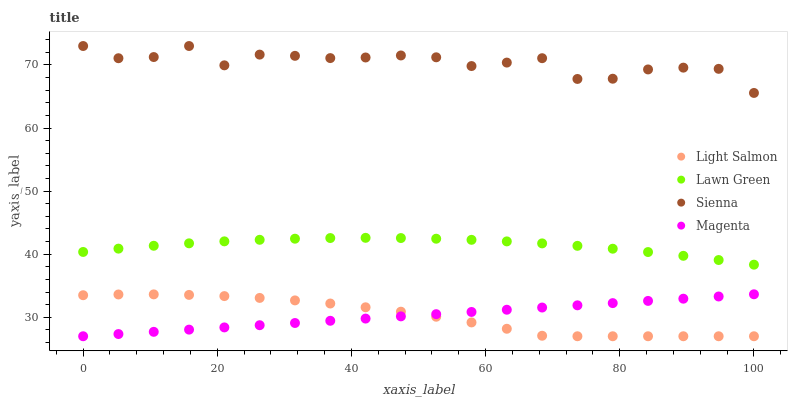Does Light Salmon have the minimum area under the curve?
Answer yes or no. Yes. Does Sienna have the maximum area under the curve?
Answer yes or no. Yes. Does Lawn Green have the minimum area under the curve?
Answer yes or no. No. Does Lawn Green have the maximum area under the curve?
Answer yes or no. No. Is Magenta the smoothest?
Answer yes or no. Yes. Is Sienna the roughest?
Answer yes or no. Yes. Is Lawn Green the smoothest?
Answer yes or no. No. Is Lawn Green the roughest?
Answer yes or no. No. Does Light Salmon have the lowest value?
Answer yes or no. Yes. Does Lawn Green have the lowest value?
Answer yes or no. No. Does Sienna have the highest value?
Answer yes or no. Yes. Does Lawn Green have the highest value?
Answer yes or no. No. Is Magenta less than Sienna?
Answer yes or no. Yes. Is Sienna greater than Lawn Green?
Answer yes or no. Yes. Does Magenta intersect Light Salmon?
Answer yes or no. Yes. Is Magenta less than Light Salmon?
Answer yes or no. No. Is Magenta greater than Light Salmon?
Answer yes or no. No. Does Magenta intersect Sienna?
Answer yes or no. No. 